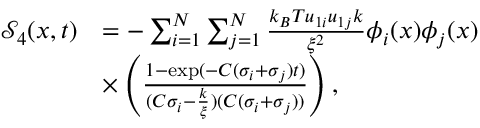Convert formula to latex. <formula><loc_0><loc_0><loc_500><loc_500>\begin{array} { r l } { \mathcal { S } _ { 4 } ( x , t ) } & { = - \sum _ { i = 1 } ^ { N } \sum _ { j = 1 } ^ { N } \frac { k _ { B } T u _ { 1 i } u _ { 1 j } k } { \xi ^ { 2 } } \phi _ { i } ( x ) \phi _ { j } ( x ) } \\ & { \times \left ( \frac { 1 - \exp ( - C ( \sigma _ { i } + \sigma _ { j } ) t ) } { ( C \sigma _ { i } - \frac { k } { \xi } ) ( C ( \sigma _ { i } + \sigma _ { j } ) ) } \right ) , } \end{array}</formula> 